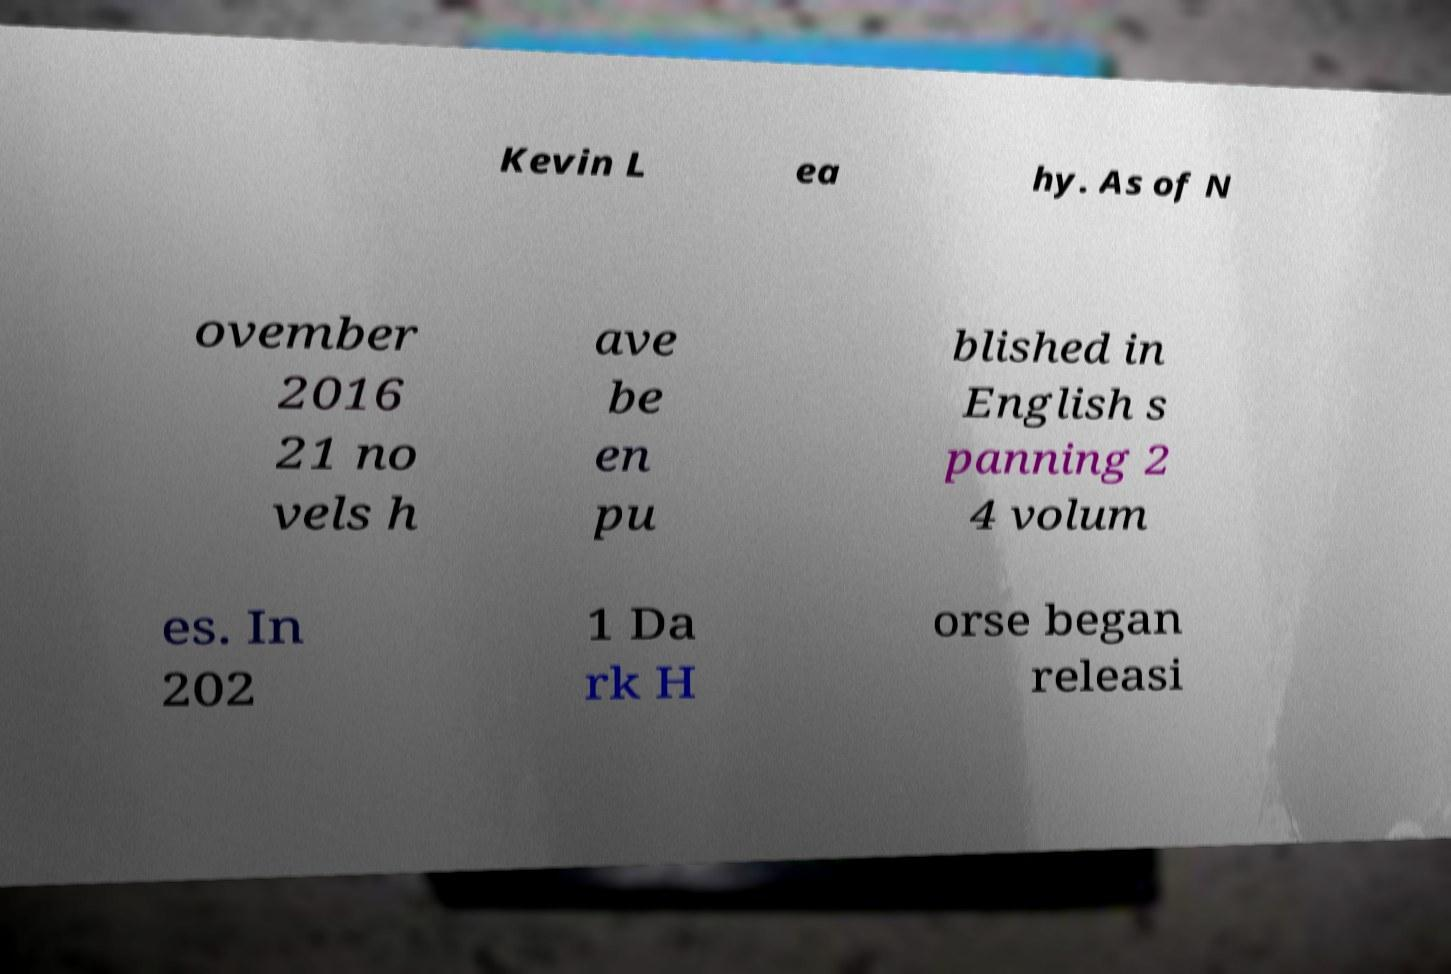Could you assist in decoding the text presented in this image and type it out clearly? Kevin L ea hy. As of N ovember 2016 21 no vels h ave be en pu blished in English s panning 2 4 volum es. In 202 1 Da rk H orse began releasi 